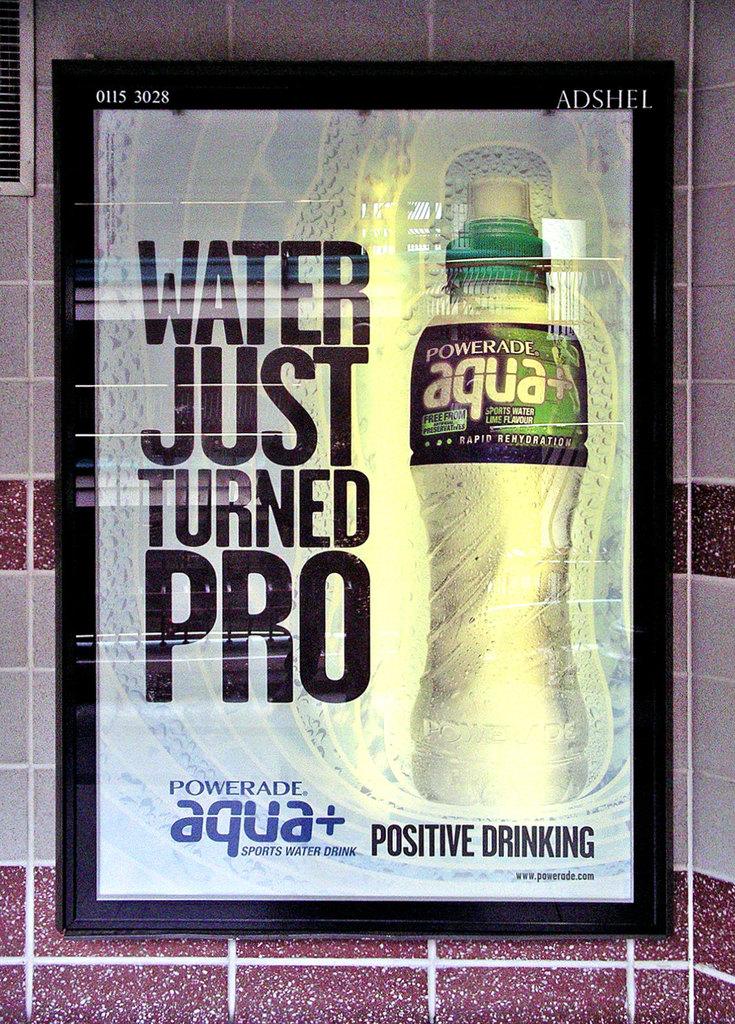What is a slogan for powerade aqua?
Your response must be concise. Water just turned pro. What type of drink is this?
Offer a very short reply. Water. 